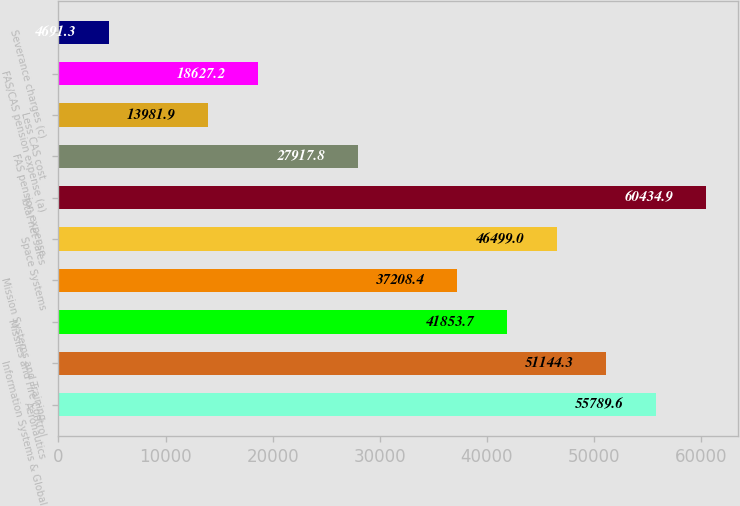<chart> <loc_0><loc_0><loc_500><loc_500><bar_chart><fcel>Aeronautics<fcel>Information Systems & Global<fcel>Missiles and Fire Control<fcel>Mission Systems and Training<fcel>Space Systems<fcel>Total net sales<fcel>FAS pension expense<fcel>Less CAS cost<fcel>FAS/CAS pension expense (a)<fcel>Severance charges (c)<nl><fcel>55789.6<fcel>51144.3<fcel>41853.7<fcel>37208.4<fcel>46499<fcel>60434.9<fcel>27917.8<fcel>13981.9<fcel>18627.2<fcel>4691.3<nl></chart> 